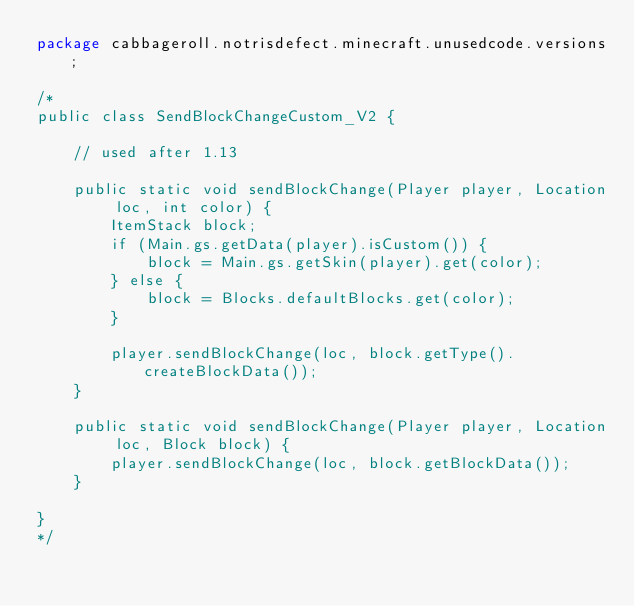<code> <loc_0><loc_0><loc_500><loc_500><_Java_>package cabbageroll.notrisdefect.minecraft.unusedcode.versions;

/*
public class SendBlockChangeCustom_V2 {

    // used after 1.13

    public static void sendBlockChange(Player player, Location loc, int color) {
        ItemStack block;
        if (Main.gs.getData(player).isCustom()) {
            block = Main.gs.getSkin(player).get(color);
        } else {
            block = Blocks.defaultBlocks.get(color);
        }

        player.sendBlockChange(loc, block.getType().createBlockData());
    }

    public static void sendBlockChange(Player player, Location loc, Block block) {
        player.sendBlockChange(loc, block.getBlockData());
    }

}
*/</code> 